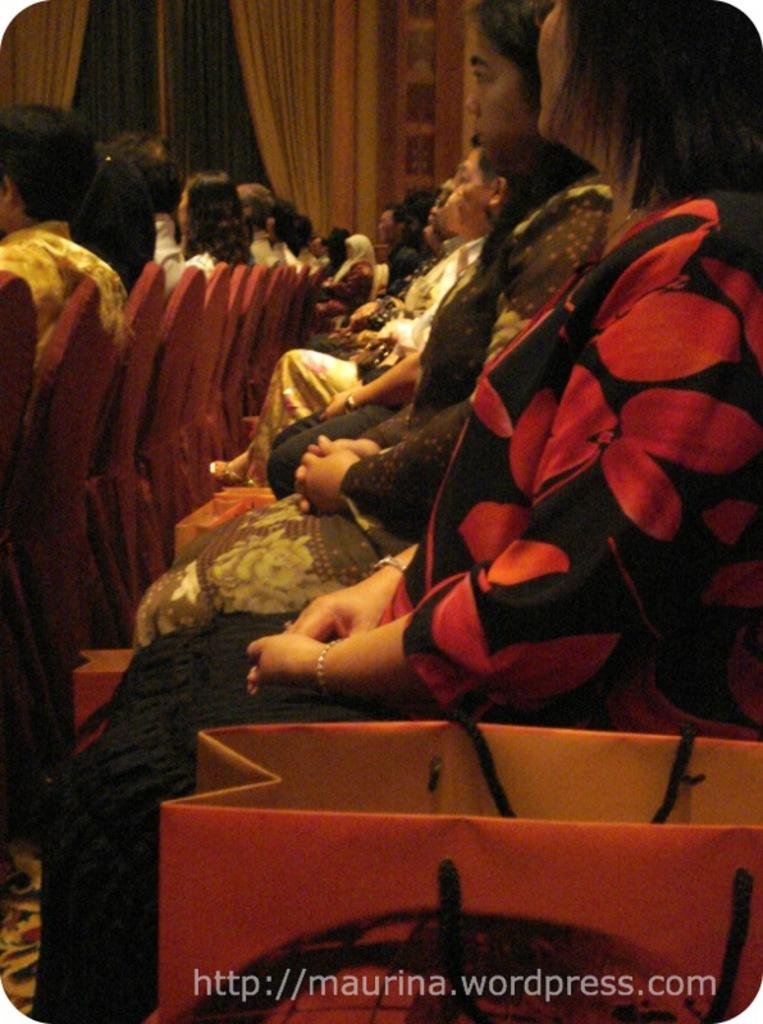What are the people in the image doing? People are sitting on chairs in the image. Can you describe any objects or accessories that the people have? There is a woman with a bag beside her. What type of window treatment is visible in the image? There are curtains in the image. Is there any text or marking on the image itself? Yes, there is a watermark at the bottom of the image. What type of mountain can be seen in the background of the image? There are no mountains visible in the image; it primarily features people sitting on chairs and a woman with a bag. 